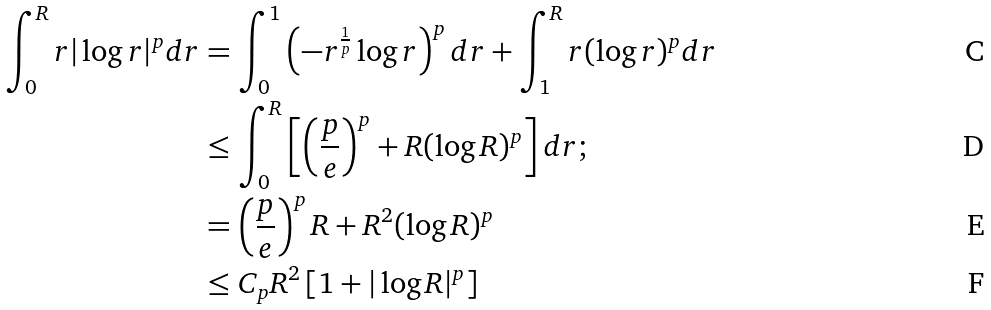<formula> <loc_0><loc_0><loc_500><loc_500>\int _ { 0 } ^ { R } r | \log r | ^ { p } d r & = \int _ { 0 } ^ { 1 } \left ( - r ^ { \frac { 1 } { p } } \log r \right ) ^ { p } d r + \int _ { 1 } ^ { R } r ( \log r ) ^ { p } d r \\ & \leq \int _ { 0 } ^ { R } \left [ \left ( \frac { p } { e } \right ) ^ { p } + R ( \log R ) ^ { p } \right ] d r ; \\ & = \left ( \frac { p } { e } \right ) ^ { p } R + R ^ { 2 } ( \log R ) ^ { p } \\ & \leq C _ { p } R ^ { 2 } \left [ 1 + | \log R | ^ { p } \right ]</formula> 